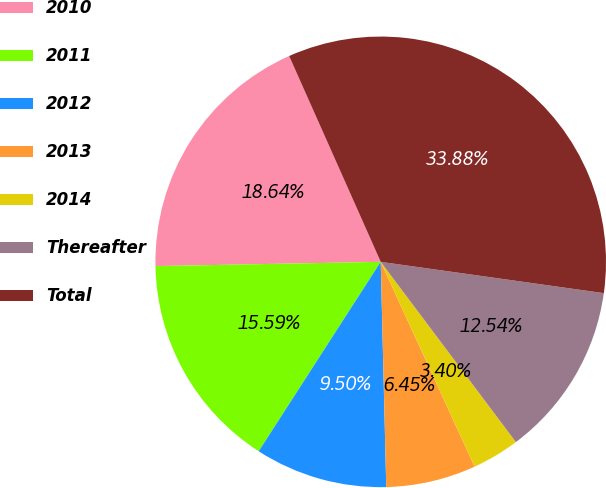Convert chart. <chart><loc_0><loc_0><loc_500><loc_500><pie_chart><fcel>2010<fcel>2011<fcel>2012<fcel>2013<fcel>2014<fcel>Thereafter<fcel>Total<nl><fcel>18.64%<fcel>15.59%<fcel>9.5%<fcel>6.45%<fcel>3.4%<fcel>12.54%<fcel>33.88%<nl></chart> 